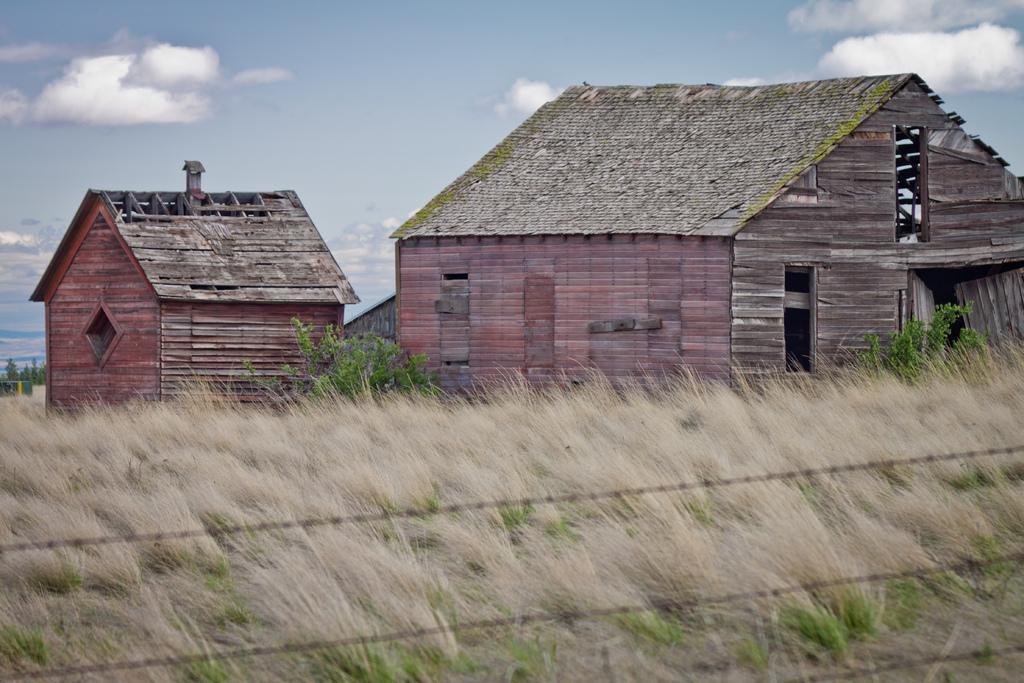How would you summarize this image in a sentence or two? This picture shows couple of wooden houses and we see grass and few plants and we see a blue cloudy sky. 